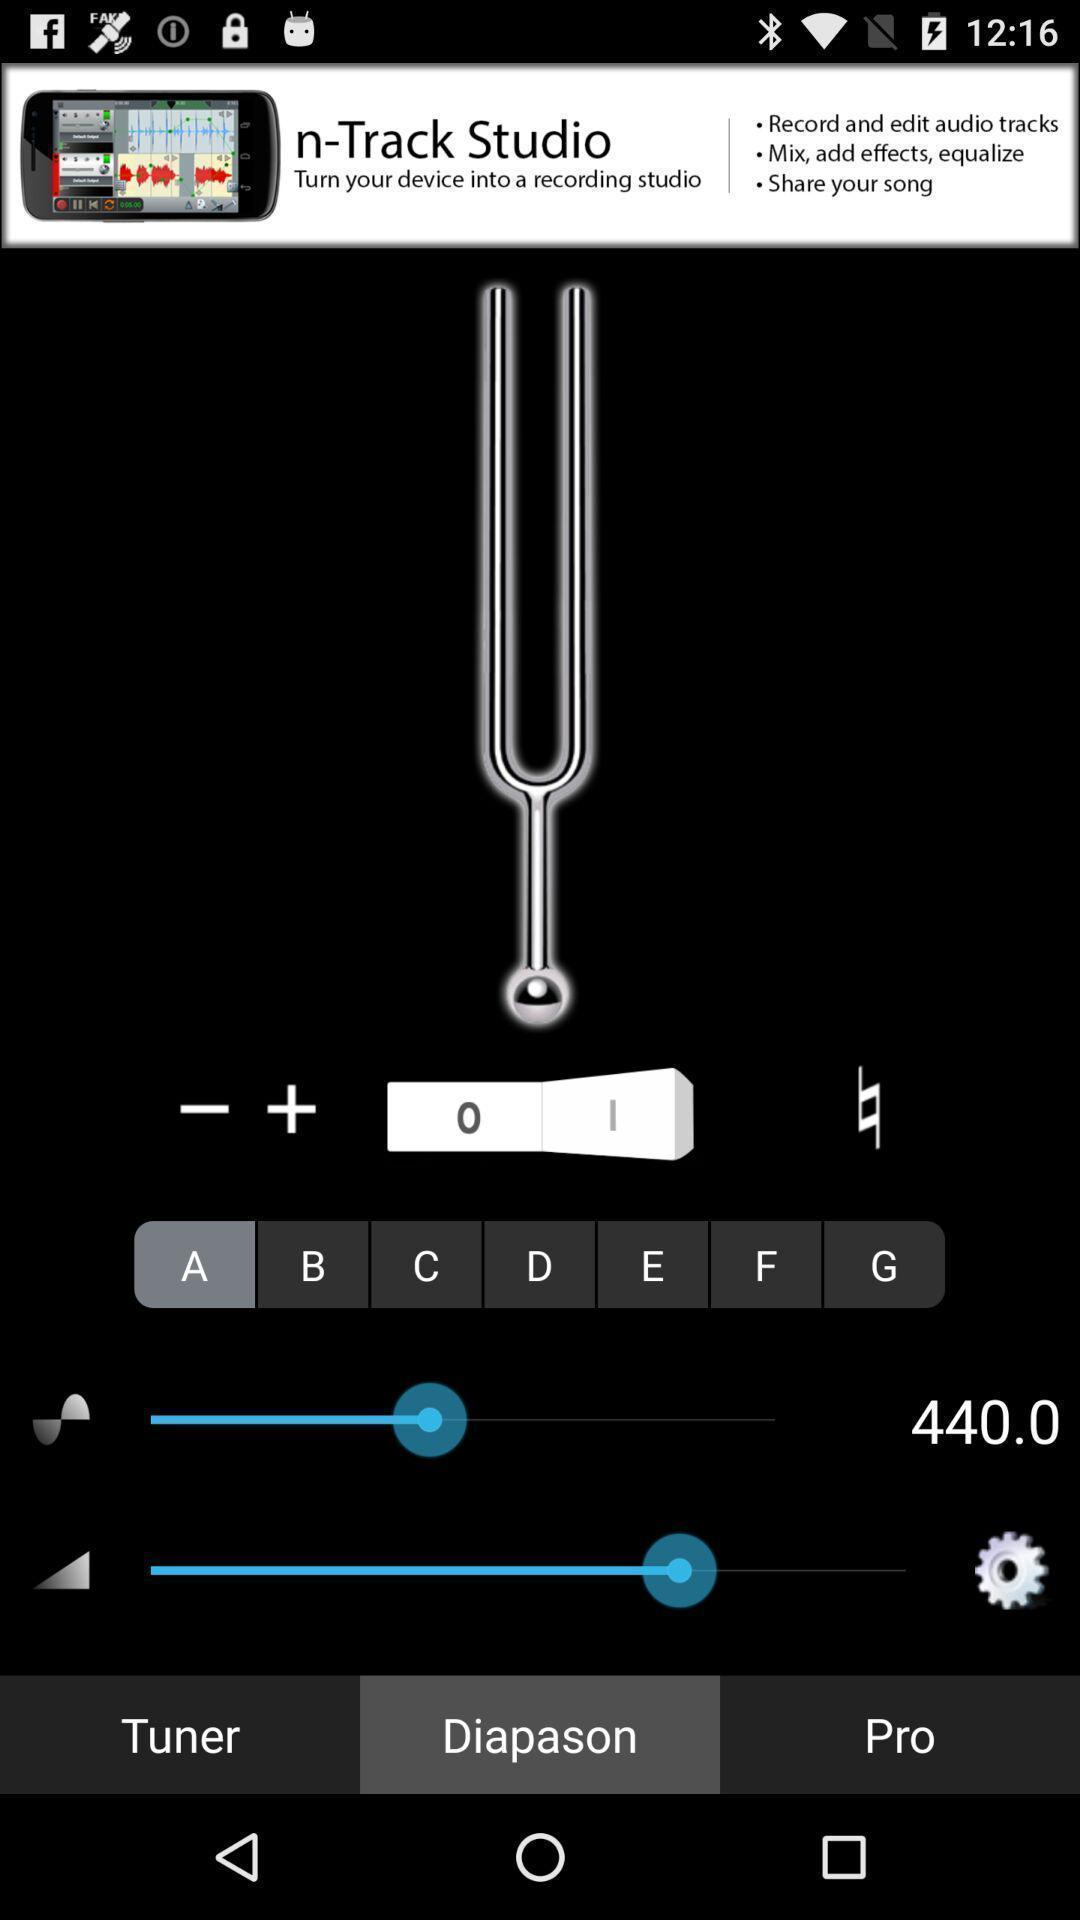Tell me what you see in this picture. Screen showing diapason option. 